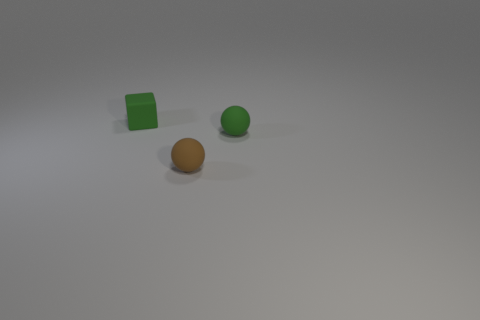Can you describe the shapes of the objects? Certainly! There are three distinct shapes here: a cube, a sphere, and a cylindrical object. 